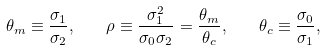<formula> <loc_0><loc_0><loc_500><loc_500>\theta _ { m } \equiv \frac { \sigma _ { 1 } } { \sigma _ { 2 } } , \quad \rho \equiv \frac { \sigma _ { 1 } ^ { 2 } } { \sigma _ { 0 } \sigma _ { 2 } } = \frac { \theta _ { m } } { \theta _ { c } } , \quad \theta _ { c } \equiv \frac { \sigma _ { 0 } } { \sigma _ { 1 } } ,</formula> 